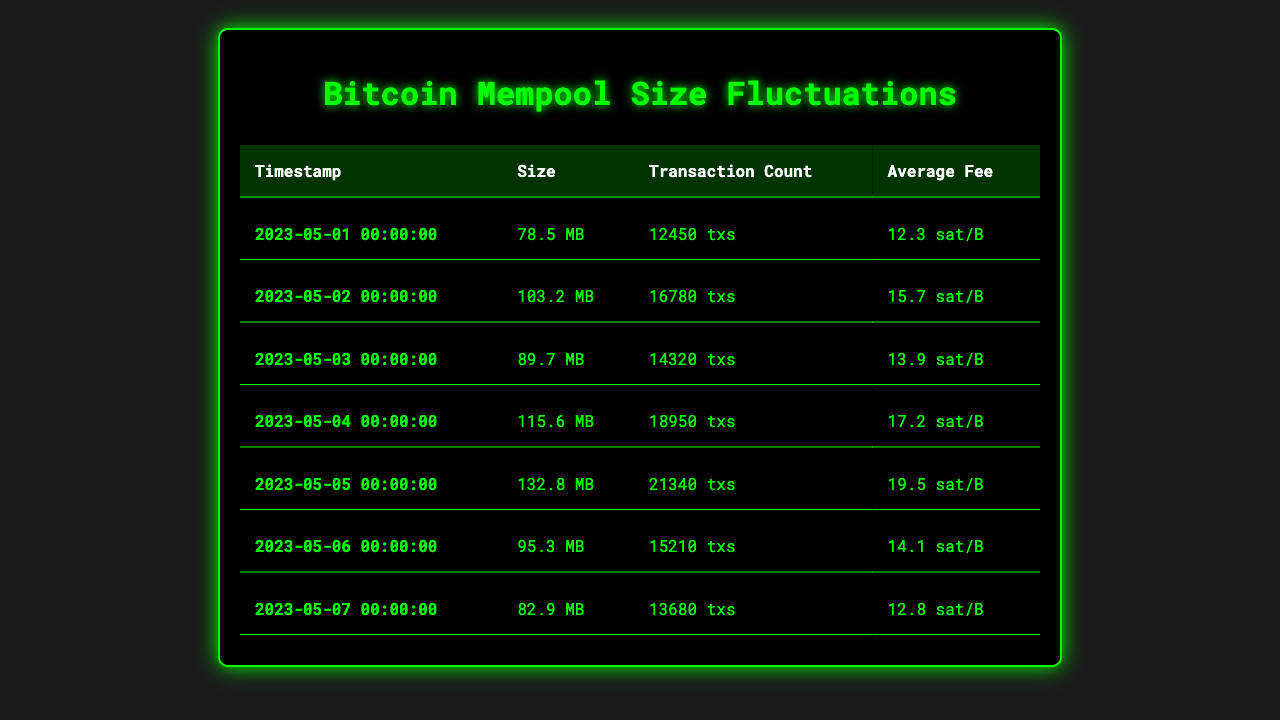What is the maximum mempool size recorded in the table? The maximum mempool size is found by looking at all the values in the "Size" column. Scanning through the data, the highest value is 132.8 MB recorded on 2023-05-05.
Answer: 132.8 MB Which day had the highest average fee in satoshis per byte? To find the highest average fee, examine the "Average Fee" column. The maximum value is 19.5 sat/B on 2023-05-05.
Answer: 2023-05-05 What was the total transaction count over the week? Adding all the transaction counts from the "Transaction Count" column yields 12450 + 16780 + 14320 + 18950 + 21340 + 15210 + 13680 = 108730.
Answer: 108730 Is it true that the mempool size decreased from May 5 to May 6? Comparing the sizes from these two days shows that 132.8 MB (May 5) is greater than 95.3 MB (May 6), confirming a decrease.
Answer: Yes What is the average mempool size for the week? The average mempool size is calculated by summing the sizes (78.5 + 103.2 + 89.7 + 115.6 + 132.8 + 95.3 + 82.9 = 697.0) and dividing by 7, giving 697.0 / 7 ≈ 99.57 MB.
Answer: 99.57 MB On which day did the transaction count exceed 20,000? By checking the "Transaction Count" column, the only day exceeding 20,000 transactions is May 5 with a count of 21340.
Answer: May 5 Was there a day where the average fee was less than 13 sat/B? Evaluating the "Average Fee" column reveals that on May 1, the fee is 12.3 sat/B, which is less than 13.
Answer: Yes How many days had a mempool size greater than 100 MB? Examining the "Size" column, four days exceed 100 MB: May 2 (103.2 MB), May 4 (115.6 MB), May 5 (132.8 MB), and May 3 (89.7 MB) does not count. Hence, it's 3 days.
Answer: 3 days What was the trend in average fees throughout the week? By reviewing the "Average Fee" values chronologically, they generally increased from 12.3 on May 1 to 19.5 on May 5, suggesting a rising trend, then slightly decreased to 12.8 on May 7.
Answer: Increasing then decreasing What was the smallest mempool size recorded in the week? Scanning the "Size" column shows that 78.5 MB on May 1 is the lowest value.
Answer: 78.5 MB 